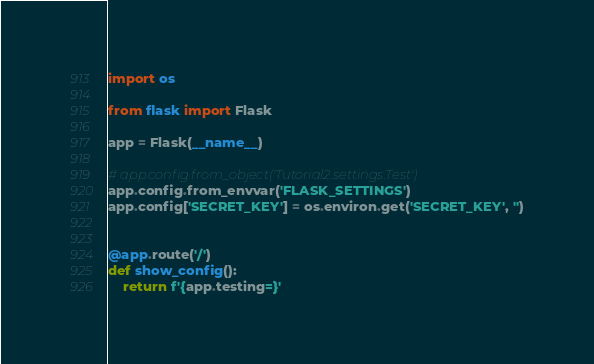<code> <loc_0><loc_0><loc_500><loc_500><_Python_>import os

from flask import Flask

app = Flask(__name__)

# app.config.from_object('Tutorial2.settings.Test')
app.config.from_envvar('FLASK_SETTINGS')
app.config['SECRET_KEY'] = os.environ.get('SECRET_KEY', '')


@app.route('/')
def show_config():
    return f'{app.testing=}'
</code> 